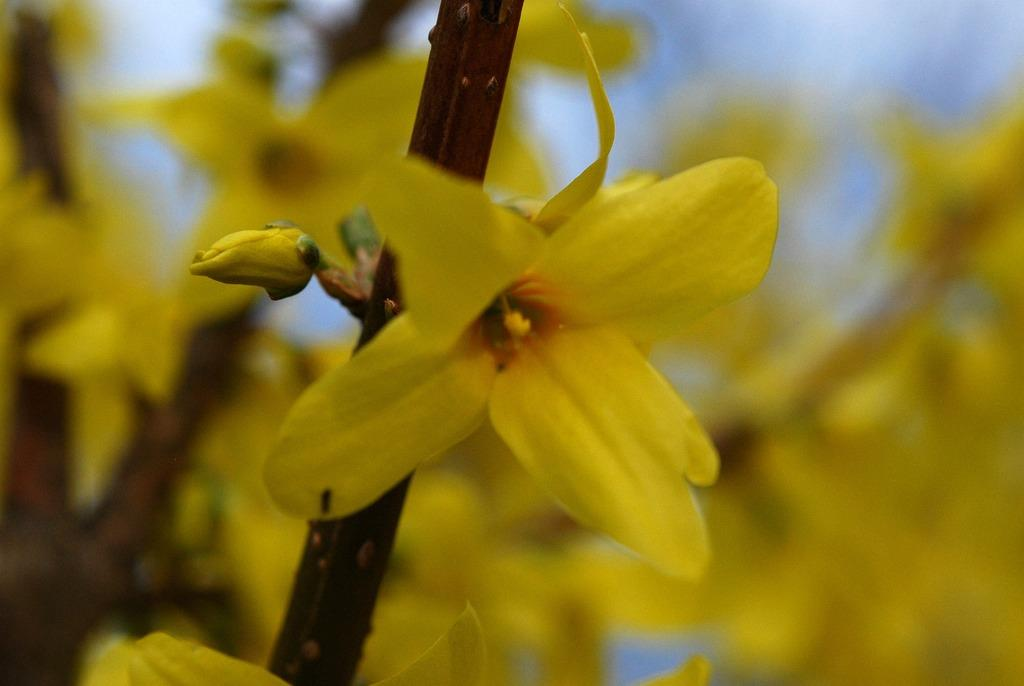What type of plants can be seen in the image? There are flowers in the image. What color are the flowers? The flowers are yellow in color. How many family members are visible in the image? There are no family members present in the image; it only features flowers. What type of calendar is shown on the flowers? There is no calendar present in the image; it only features flowers. 